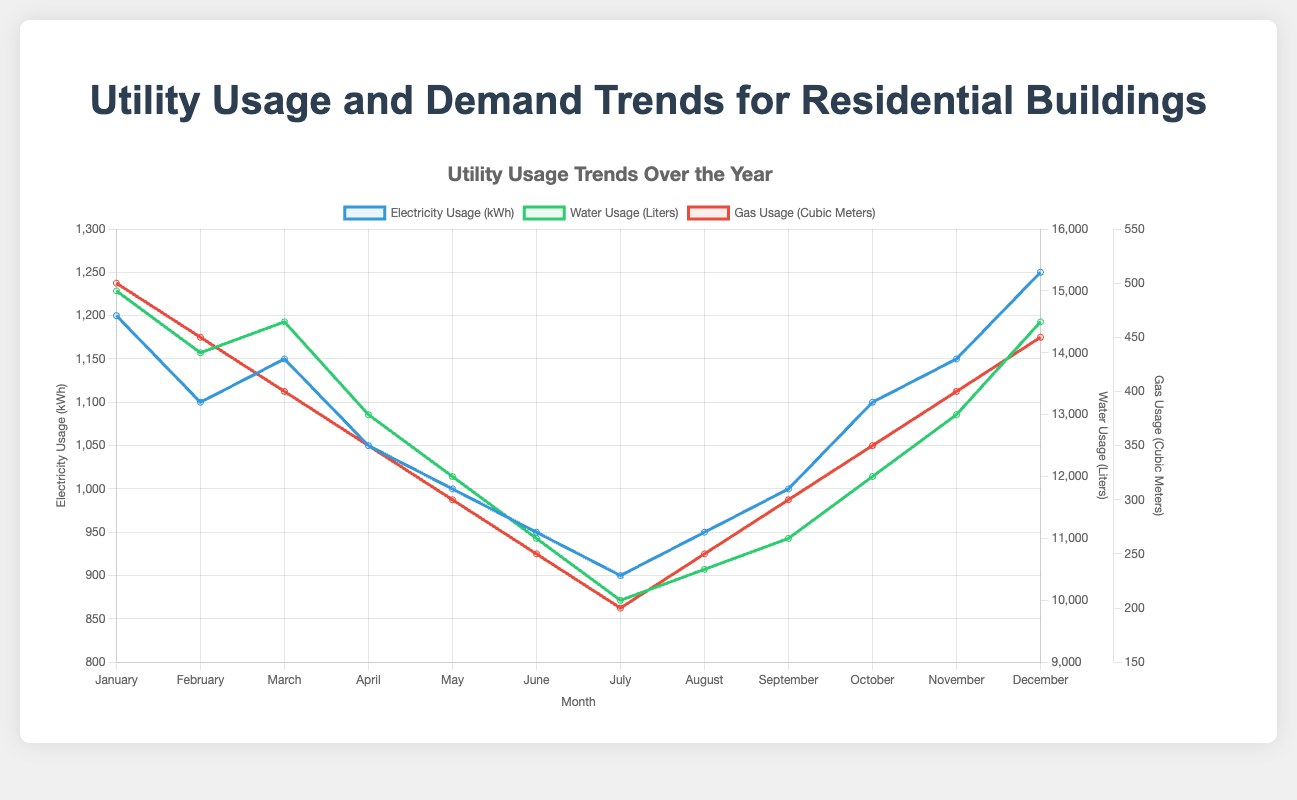Which month has the highest electricity usage? By observing the electricity usage line marked in blue, the peak occurs in January.
Answer: January What is the difference in gas usage between the month with the highest usage and the month with the lowest usage? The highest gas usage is in January with 500 cubic meters, and the lowest is in July with 200 cubic meters. The difference is 500 - 200 = 300 cubic meters.
Answer: 300 cubic meters How does water usage in March compare to that in September? The green line for water usage indicates that March has 14500 liters and September has 11000 liters. Thus, March has more water usage than September.
Answer: March has more water usage Which utility shows the most significant decrease from January to July? By comparing the slopes of the three utility lines from January to July, the gas usage (red line) shows the largest decrease from 500 to 200 cubic meters.
Answer: Gas usage What is the average electricity usage over the year? Summing up electricity usage values from all months: 1200 + 1100 + 1150 + 1050 + 1000 + 950 + 900 + 950 + 1000 + 1100 + 1150 + 1250 = 13700 kWh. There are 12 months, so the average is 13700 / 12 ≈ 1142 kWh.
Answer: 1142 kWh If water usage in liters and gas usage in cubic meters are summed, which month has the highest combined value? For each month, add water and gas usage values and determine the maximum:
+ January: 15000 + 500 = 15500
+ February: 14000 + 450 = 14450
+ March: 14500 + 400 = 14900
+ April: 13000 + 350 = 13350
+ May: 12000 + 300 = 12300
+ June: 11000 + 250 = 11250
+ July: 10000 + 200 = 10200
+ August: 10500 + 250 = 10750
+ September: 11000 + 300 = 11300
+ October: 12000 + 350 = 12350
+ November: 13000 + 400 = 13400
+ December: 14500 + 450 = 14950
The highest combined value is in January with 15500.
Answer: January Is there a month where the electricity usage is equal to the water usage divided by 12? Compare electricity usage values directly with water usage values divided by 12 for each month:
+ January: 1200 vs. 15000/12 = 1250 (not equal)
+ February: 1100 vs. 14000/12 ≈ 1167 (not equal)
+ March: 1150 vs. 14500/12 ≈ 1208 (not equal)
+ April: 1050 vs. 13000/12 ≈ 1083 (not equal)
+ May: 1000 vs. 12000/12 = 1000 (equal)
+ June: 950 vs. 11000/12 ≈ 917 (not equal)
+ July: 900 vs. 10000/12 ≈ 833 (not equal)
+ August: 950 vs. 10500/12 ≈ 875 (not equal)
+ September: 1000 vs. 11000/12 ≈ 917 (not equal)
+ October: 1100 vs. 12000/12 = 1000 (not equal)
+ November: 1150 vs. 13000/12 ≈ 1083 (not equal)
+ December: 1250 vs. 14500/12 ≈ 1208 (not equal)
Only May shows equality.
Answer: May 